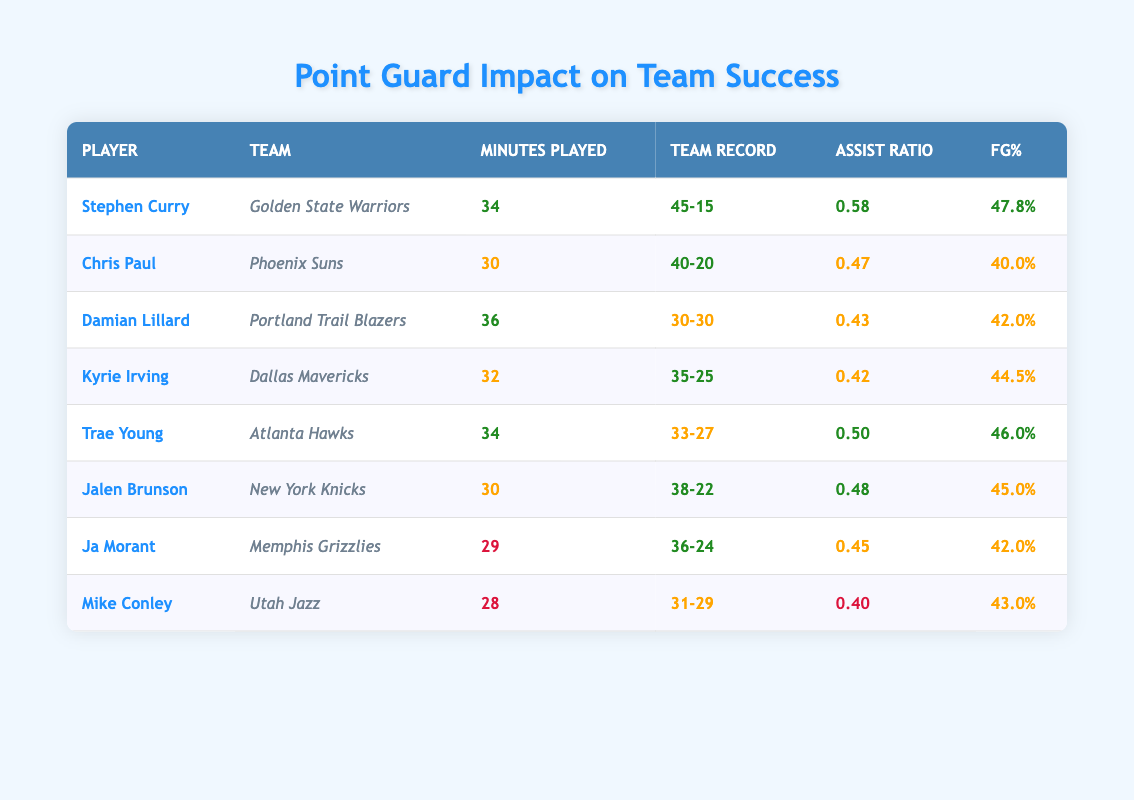What is the team record for Stephen Curry? The table lists Stephen Curry's team record in the "Team Record" column, which shows he has a record of 45 wins and 15 losses.
Answer: 45-15 Which player has the lowest field goal percentage? To answer this, I look across the "FG%" column for all players. Mike Conley has the lowest field goal percentage at 43.0%.
Answer: 43.0% What is the combined number of wins for the players with more than 30 minutes played? I filter for players with more than 30 minutes played: Stephen Curry (45), Chris Paul (40), Damian Lillard (30), Kyrie Irving (35), Trae Young (33), Jalen Brunson (38). Summing these wins yields 45 + 40 + 30 + 35 + 33 + 38 = 251.
Answer: 251 Is Chris Paul’s assist ratio greater than Kyrie Irving’s? Checking the "Assist Ratio" for both players, Chris Paul has 0.47 while Kyrie Irving has 0.42. Thus, Chris Paul's assist ratio is indeed greater than Kyrie Irving's.
Answer: Yes What is the average number of losses for players who played 30 or fewer minutes? I gather the teams with 30 or fewer minutes: Mike Conley (29 losses), Ja Morant (24 losses). Calculating the average: (29 + 24) / 2 = 26.5.
Answer: 26.5 